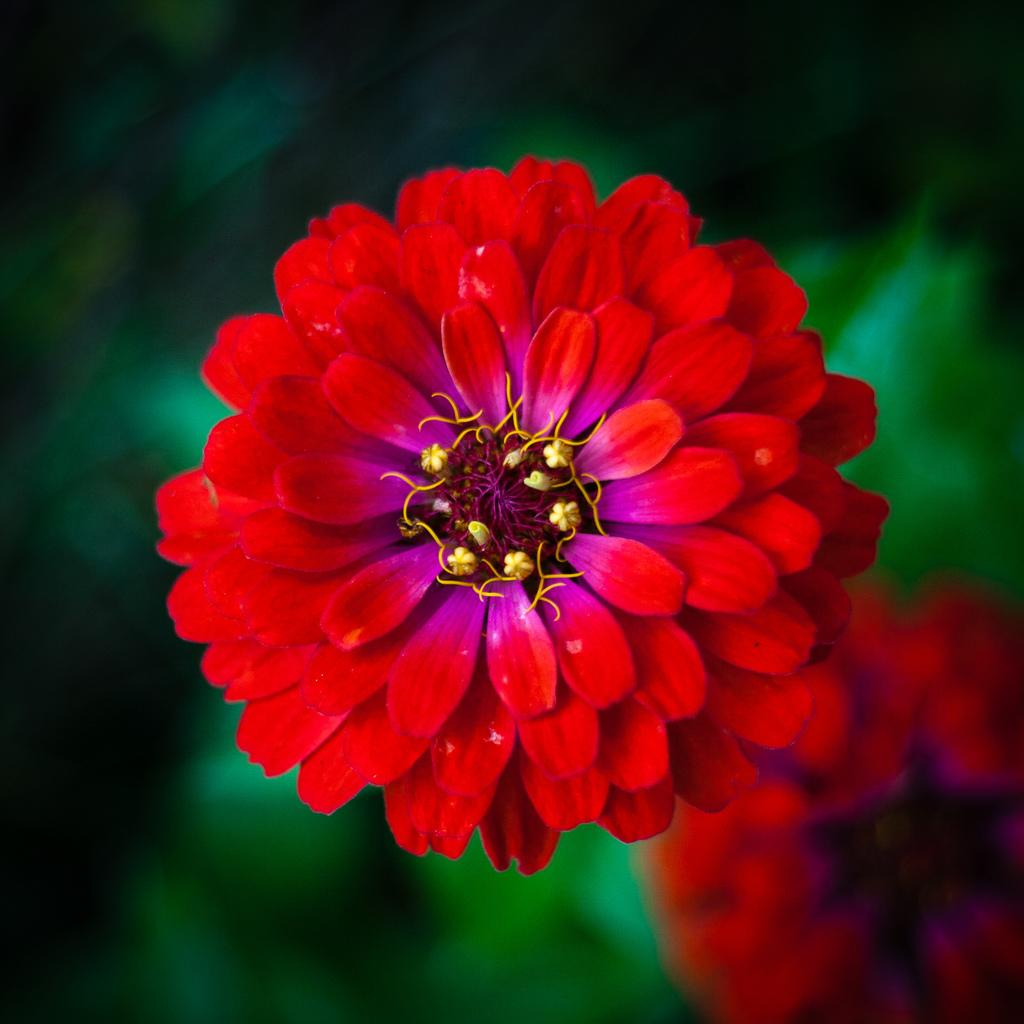What is the main subject of the image? There is a red flower in the image. Where is the flower located in the image? The flower is in the middle of the image. How many petals does the flower have? The flower has many petals. What direction is the harbor facing in the image? There is no harbor present in the image, so it's not possible to determine the direction it might be facing. 